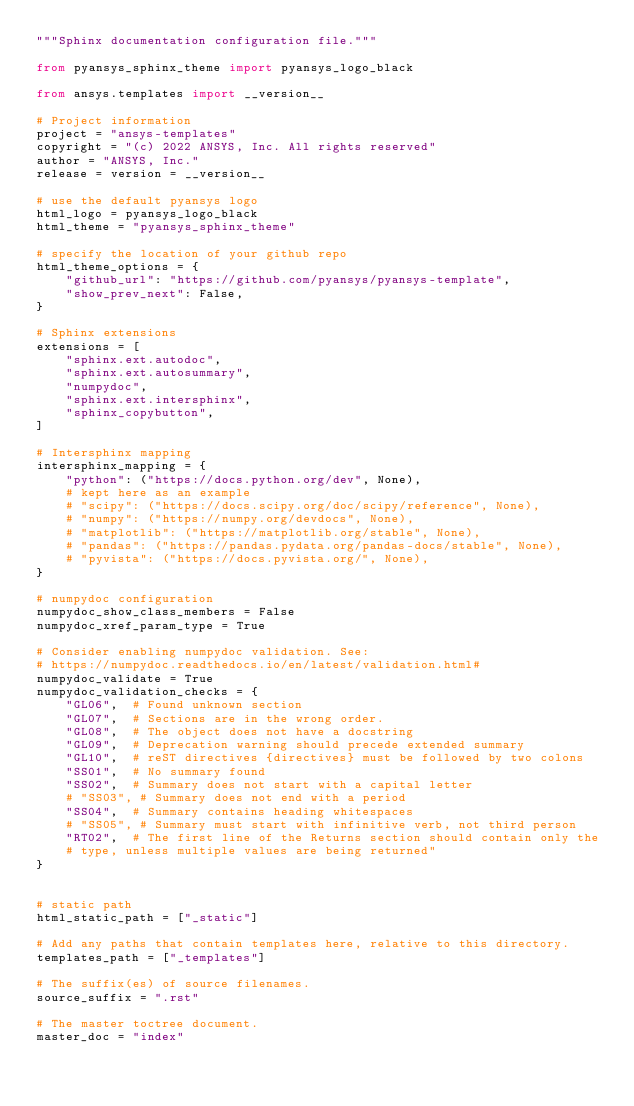Convert code to text. <code><loc_0><loc_0><loc_500><loc_500><_Python_>"""Sphinx documentation configuration file."""

from pyansys_sphinx_theme import pyansys_logo_black

from ansys.templates import __version__

# Project information
project = "ansys-templates"
copyright = "(c) 2022 ANSYS, Inc. All rights reserved"
author = "ANSYS, Inc."
release = version = __version__

# use the default pyansys logo
html_logo = pyansys_logo_black
html_theme = "pyansys_sphinx_theme"

# specify the location of your github repo
html_theme_options = {
    "github_url": "https://github.com/pyansys/pyansys-template",
    "show_prev_next": False,
}

# Sphinx extensions
extensions = [
    "sphinx.ext.autodoc",
    "sphinx.ext.autosummary",
    "numpydoc",
    "sphinx.ext.intersphinx",
    "sphinx_copybutton",
]

# Intersphinx mapping
intersphinx_mapping = {
    "python": ("https://docs.python.org/dev", None),
    # kept here as an example
    # "scipy": ("https://docs.scipy.org/doc/scipy/reference", None),
    # "numpy": ("https://numpy.org/devdocs", None),
    # "matplotlib": ("https://matplotlib.org/stable", None),
    # "pandas": ("https://pandas.pydata.org/pandas-docs/stable", None),
    # "pyvista": ("https://docs.pyvista.org/", None),
}

# numpydoc configuration
numpydoc_show_class_members = False
numpydoc_xref_param_type = True

# Consider enabling numpydoc validation. See:
# https://numpydoc.readthedocs.io/en/latest/validation.html#
numpydoc_validate = True
numpydoc_validation_checks = {
    "GL06",  # Found unknown section
    "GL07",  # Sections are in the wrong order.
    "GL08",  # The object does not have a docstring
    "GL09",  # Deprecation warning should precede extended summary
    "GL10",  # reST directives {directives} must be followed by two colons
    "SS01",  # No summary found
    "SS02",  # Summary does not start with a capital letter
    # "SS03", # Summary does not end with a period
    "SS04",  # Summary contains heading whitespaces
    # "SS05", # Summary must start with infinitive verb, not third person
    "RT02",  # The first line of the Returns section should contain only the
    # type, unless multiple values are being returned"
}


# static path
html_static_path = ["_static"]

# Add any paths that contain templates here, relative to this directory.
templates_path = ["_templates"]

# The suffix(es) of source filenames.
source_suffix = ".rst"

# The master toctree document.
master_doc = "index"
</code> 